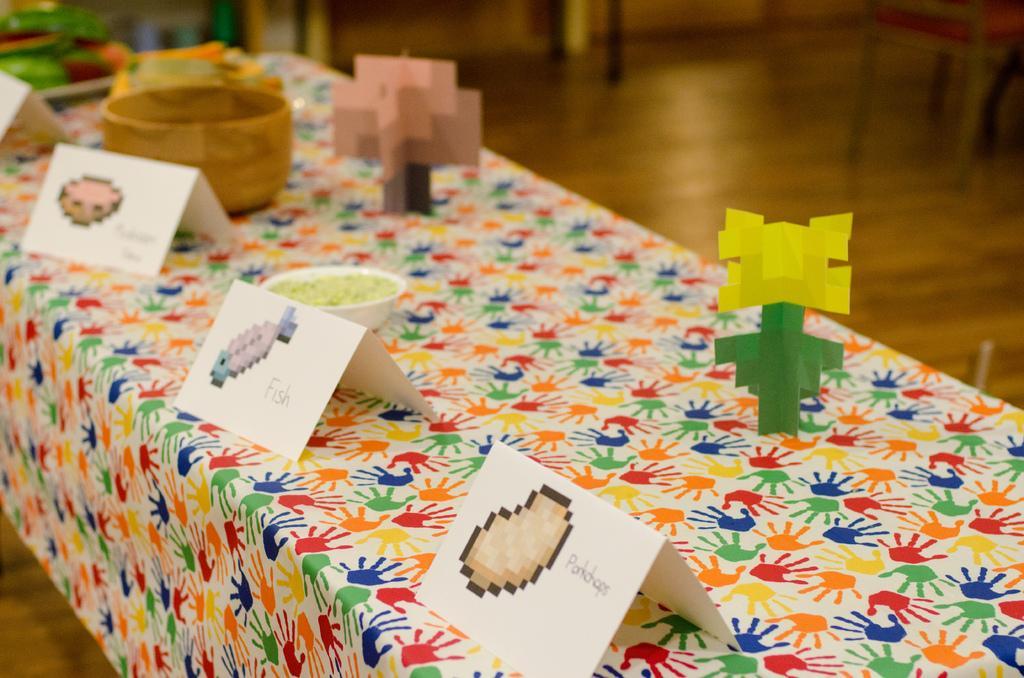Could you give a brief overview of what you see in this image? In this image we can see pictures on the cards, an item in a bowl, design papers and objects on a table. In the background we can see chairs on the floor and other objects. 